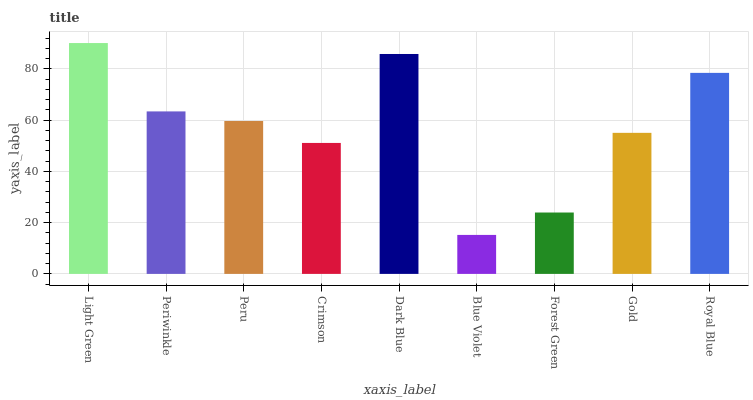Is Blue Violet the minimum?
Answer yes or no. Yes. Is Light Green the maximum?
Answer yes or no. Yes. Is Periwinkle the minimum?
Answer yes or no. No. Is Periwinkle the maximum?
Answer yes or no. No. Is Light Green greater than Periwinkle?
Answer yes or no. Yes. Is Periwinkle less than Light Green?
Answer yes or no. Yes. Is Periwinkle greater than Light Green?
Answer yes or no. No. Is Light Green less than Periwinkle?
Answer yes or no. No. Is Peru the high median?
Answer yes or no. Yes. Is Peru the low median?
Answer yes or no. Yes. Is Blue Violet the high median?
Answer yes or no. No. Is Crimson the low median?
Answer yes or no. No. 